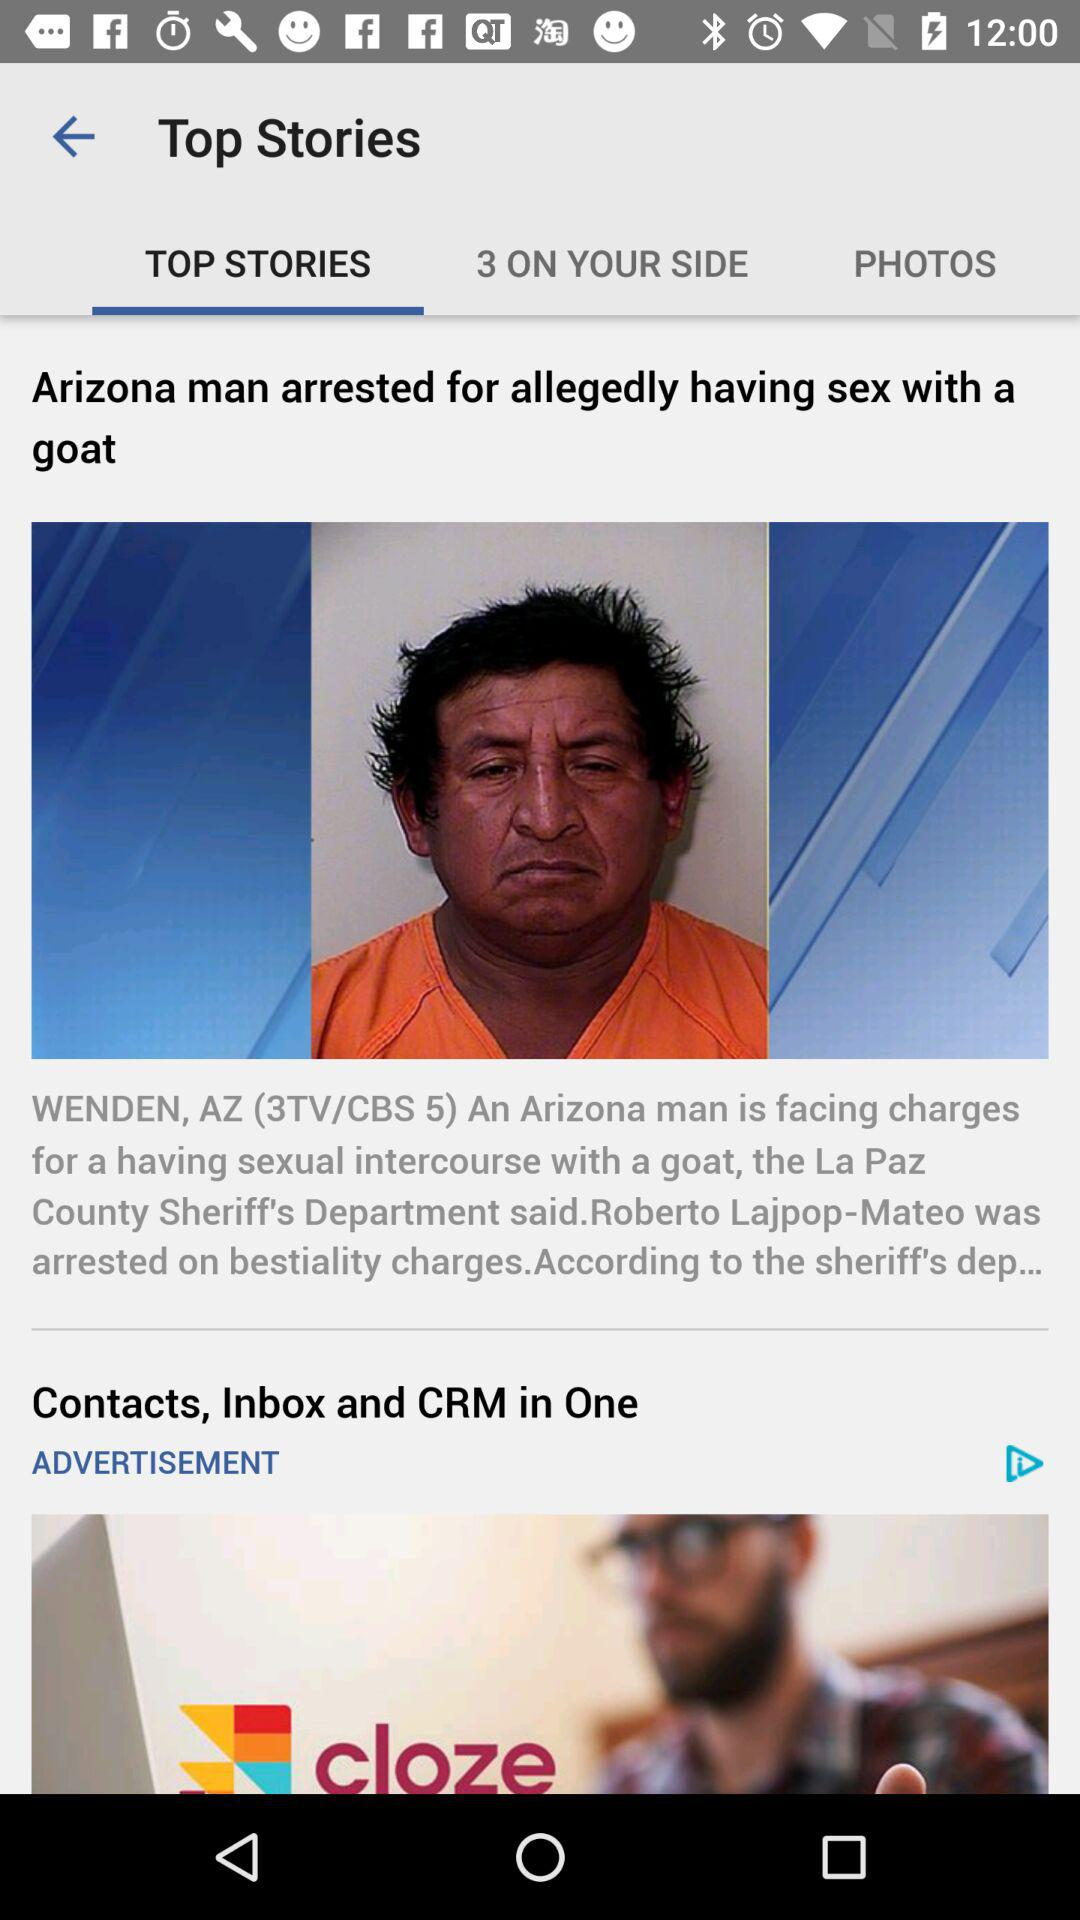Which tab is selected? The selected tab is "TOP STORIES". 